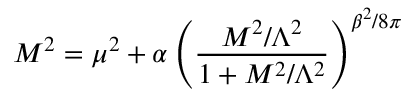Convert formula to latex. <formula><loc_0><loc_0><loc_500><loc_500>M ^ { 2 } = \mu ^ { 2 } + \alpha \left ( \frac { M ^ { 2 } / \Lambda ^ { 2 } } { 1 + M ^ { 2 } / \Lambda ^ { 2 } } \right ) ^ { \beta ^ { 2 } / 8 \pi }</formula> 